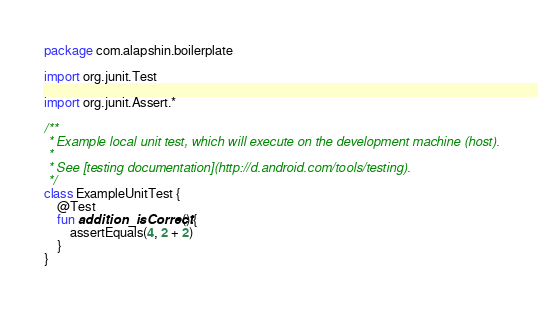<code> <loc_0><loc_0><loc_500><loc_500><_Kotlin_>package com.alapshin.boilerplate

import org.junit.Test

import org.junit.Assert.*

/**
 * Example local unit test, which will execute on the development machine (host).
 *
 * See [testing documentation](http://d.android.com/tools/testing).
 */
class ExampleUnitTest {
    @Test
    fun addition_isCorrect() {
        assertEquals(4, 2 + 2)
    }
}
</code> 